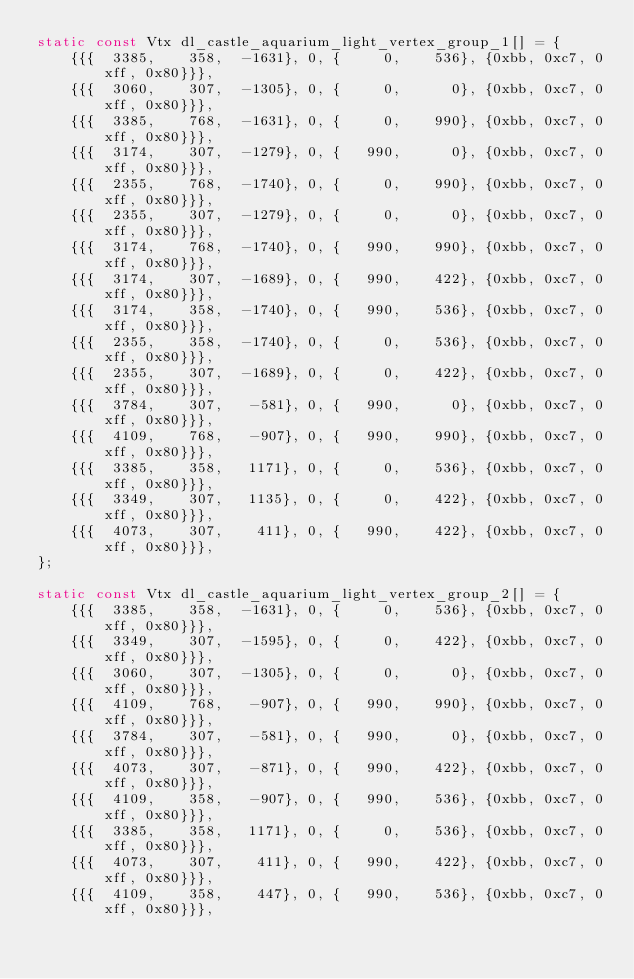Convert code to text. <code><loc_0><loc_0><loc_500><loc_500><_C_>static const Vtx dl_castle_aquarium_light_vertex_group_1[] = {
    {{{  3385,    358,  -1631}, 0, {     0,    536}, {0xbb, 0xc7, 0xff, 0x80}}},
    {{{  3060,    307,  -1305}, 0, {     0,      0}, {0xbb, 0xc7, 0xff, 0x80}}},
    {{{  3385,    768,  -1631}, 0, {     0,    990}, {0xbb, 0xc7, 0xff, 0x80}}},
    {{{  3174,    307,  -1279}, 0, {   990,      0}, {0xbb, 0xc7, 0xff, 0x80}}},
    {{{  2355,    768,  -1740}, 0, {     0,    990}, {0xbb, 0xc7, 0xff, 0x80}}},
    {{{  2355,    307,  -1279}, 0, {     0,      0}, {0xbb, 0xc7, 0xff, 0x80}}},
    {{{  3174,    768,  -1740}, 0, {   990,    990}, {0xbb, 0xc7, 0xff, 0x80}}},
    {{{  3174,    307,  -1689}, 0, {   990,    422}, {0xbb, 0xc7, 0xff, 0x80}}},
    {{{  3174,    358,  -1740}, 0, {   990,    536}, {0xbb, 0xc7, 0xff, 0x80}}},
    {{{  2355,    358,  -1740}, 0, {     0,    536}, {0xbb, 0xc7, 0xff, 0x80}}},
    {{{  2355,    307,  -1689}, 0, {     0,    422}, {0xbb, 0xc7, 0xff, 0x80}}},
    {{{  3784,    307,   -581}, 0, {   990,      0}, {0xbb, 0xc7, 0xff, 0x80}}},
    {{{  4109,    768,   -907}, 0, {   990,    990}, {0xbb, 0xc7, 0xff, 0x80}}},
    {{{  3385,    358,   1171}, 0, {     0,    536}, {0xbb, 0xc7, 0xff, 0x80}}},
    {{{  3349,    307,   1135}, 0, {     0,    422}, {0xbb, 0xc7, 0xff, 0x80}}},
    {{{  4073,    307,    411}, 0, {   990,    422}, {0xbb, 0xc7, 0xff, 0x80}}},
};

static const Vtx dl_castle_aquarium_light_vertex_group_2[] = {
    {{{  3385,    358,  -1631}, 0, {     0,    536}, {0xbb, 0xc7, 0xff, 0x80}}},
    {{{  3349,    307,  -1595}, 0, {     0,    422}, {0xbb, 0xc7, 0xff, 0x80}}},
    {{{  3060,    307,  -1305}, 0, {     0,      0}, {0xbb, 0xc7, 0xff, 0x80}}},
    {{{  4109,    768,   -907}, 0, {   990,    990}, {0xbb, 0xc7, 0xff, 0x80}}},
    {{{  3784,    307,   -581}, 0, {   990,      0}, {0xbb, 0xc7, 0xff, 0x80}}},
    {{{  4073,    307,   -871}, 0, {   990,    422}, {0xbb, 0xc7, 0xff, 0x80}}},
    {{{  4109,    358,   -907}, 0, {   990,    536}, {0xbb, 0xc7, 0xff, 0x80}}},
    {{{  3385,    358,   1171}, 0, {     0,    536}, {0xbb, 0xc7, 0xff, 0x80}}},
    {{{  4073,    307,    411}, 0, {   990,    422}, {0xbb, 0xc7, 0xff, 0x80}}},
    {{{  4109,    358,    447}, 0, {   990,    536}, {0xbb, 0xc7, 0xff, 0x80}}},</code> 